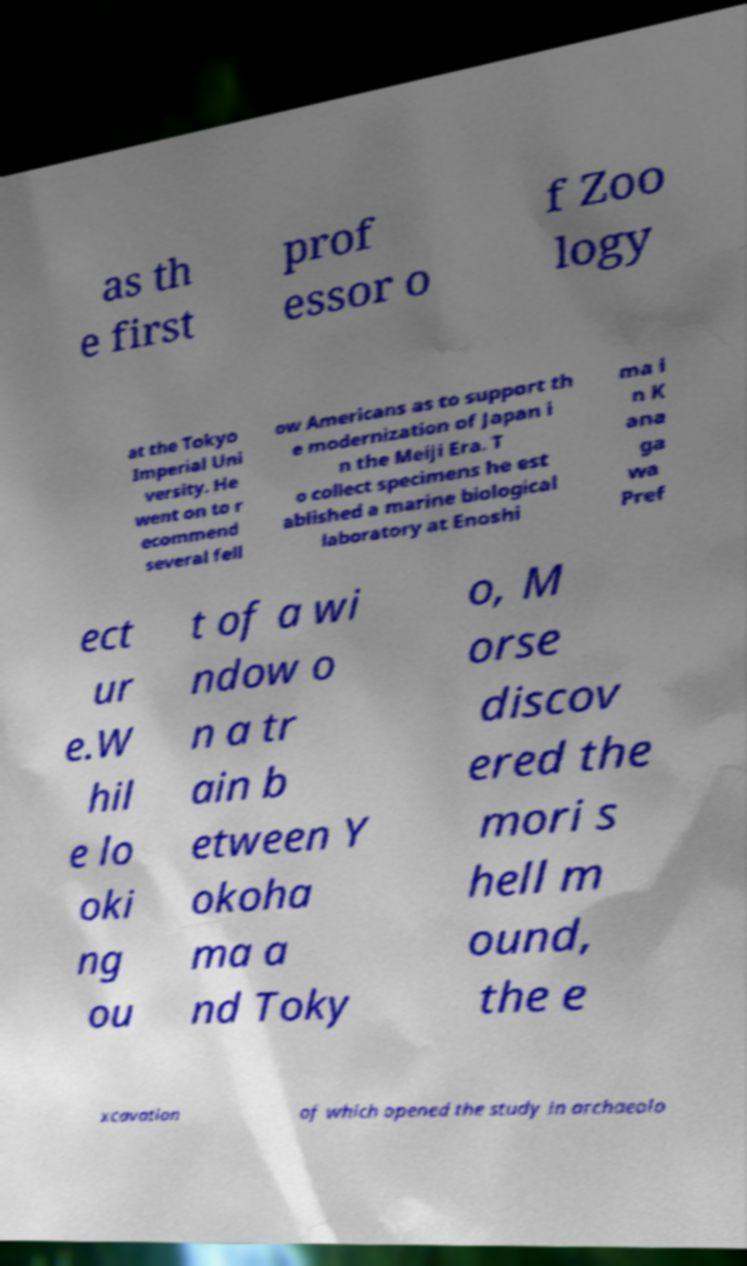There's text embedded in this image that I need extracted. Can you transcribe it verbatim? as th e first prof essor o f Zoo logy at the Tokyo Imperial Uni versity. He went on to r ecommend several fell ow Americans as to support th e modernization of Japan i n the Meiji Era. T o collect specimens he est ablished a marine biological laboratory at Enoshi ma i n K ana ga wa Pref ect ur e.W hil e lo oki ng ou t of a wi ndow o n a tr ain b etween Y okoha ma a nd Toky o, M orse discov ered the mori s hell m ound, the e xcavation of which opened the study in archaeolo 